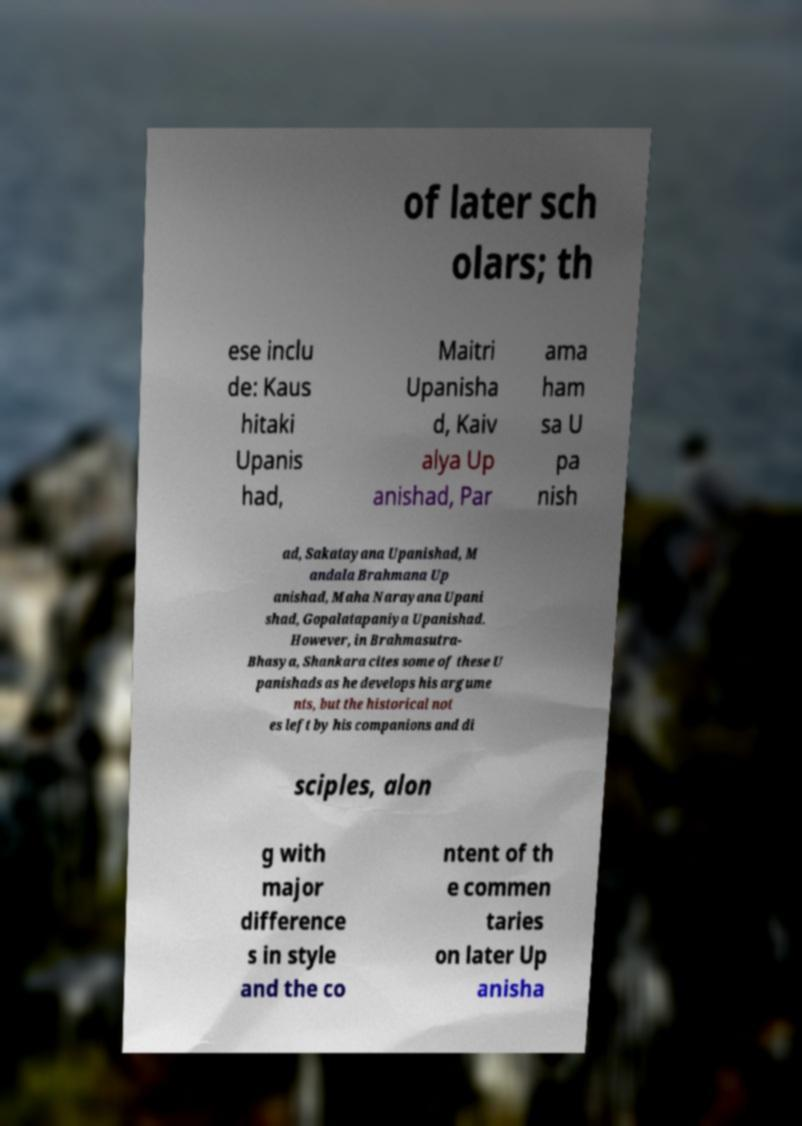What messages or text are displayed in this image? I need them in a readable, typed format. of later sch olars; th ese inclu de: Kaus hitaki Upanis had, Maitri Upanisha d, Kaiv alya Up anishad, Par ama ham sa U pa nish ad, Sakatayana Upanishad, M andala Brahmana Up anishad, Maha Narayana Upani shad, Gopalatapaniya Upanishad. However, in Brahmasutra- Bhasya, Shankara cites some of these U panishads as he develops his argume nts, but the historical not es left by his companions and di sciples, alon g with major difference s in style and the co ntent of th e commen taries on later Up anisha 